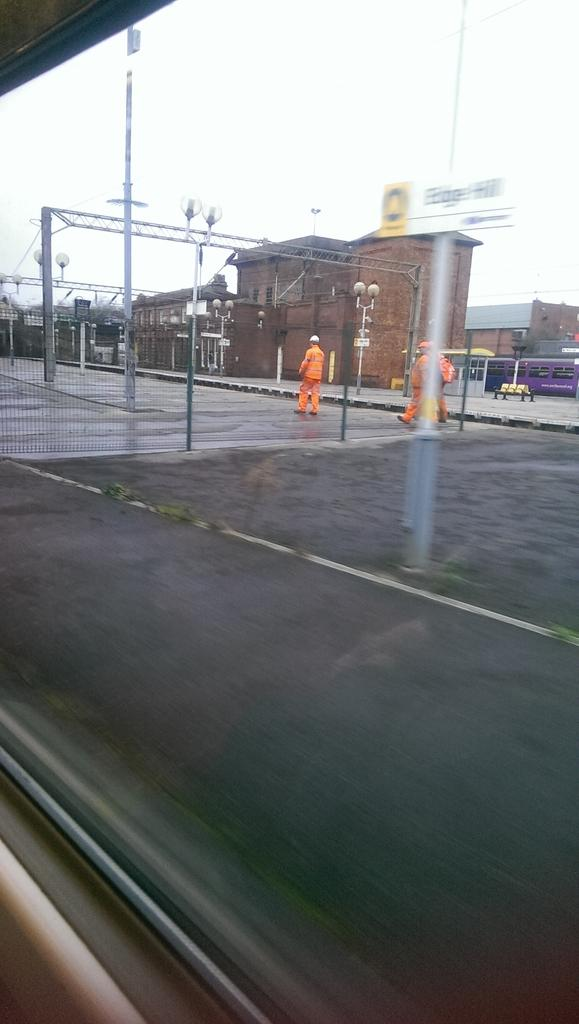What is the main subject in the foreground of the image? There is a person standing in front of the building. What can be seen in the top left corner of the image? There is a pole in the top left of the image. What is visible at the top of the image? There is a sky at the top of the image. Can you see a giraffe or a spoon in the image? No, there is no giraffe or spoon present in the image. 